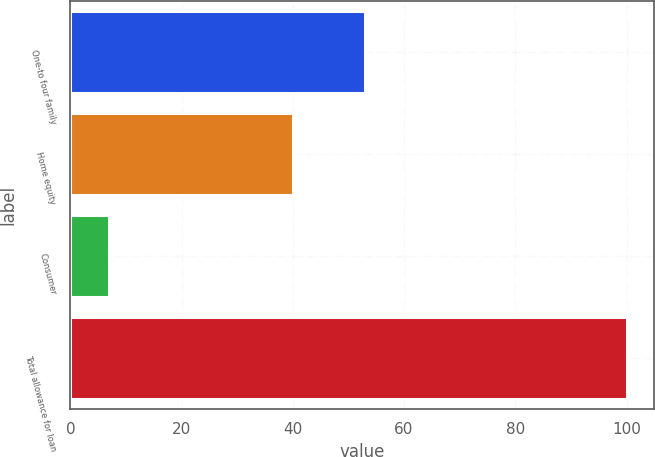Convert chart. <chart><loc_0><loc_0><loc_500><loc_500><bar_chart><fcel>One-to four family<fcel>Home equity<fcel>Consumer<fcel>Total allowance for loan<nl><fcel>53<fcel>40<fcel>7<fcel>100<nl></chart> 